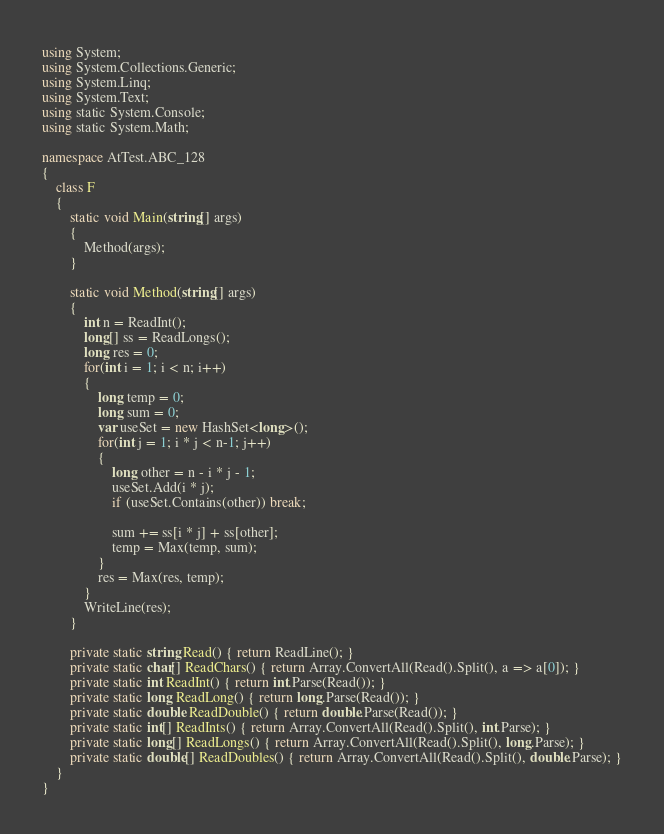Convert code to text. <code><loc_0><loc_0><loc_500><loc_500><_C#_>using System;
using System.Collections.Generic;
using System.Linq;
using System.Text;
using static System.Console;
using static System.Math;

namespace AtTest.ABC_128
{
    class F
    {
        static void Main(string[] args)
        {
            Method(args);
        }

        static void Method(string[] args)
        {
            int n = ReadInt();
            long[] ss = ReadLongs();
            long res = 0;
            for(int i = 1; i < n; i++)
            {
                long temp = 0;
                long sum = 0;
                var useSet = new HashSet<long>();
                for(int j = 1; i * j < n-1; j++)
                {
                    long other = n - i * j - 1;
                    useSet.Add(i * j);
                    if (useSet.Contains(other)) break;

                    sum += ss[i * j] + ss[other];
                    temp = Max(temp, sum);
                }
                res = Max(res, temp);
            }
            WriteLine(res);
        }

        private static string Read() { return ReadLine(); }
        private static char[] ReadChars() { return Array.ConvertAll(Read().Split(), a => a[0]); }
        private static int ReadInt() { return int.Parse(Read()); }
        private static long ReadLong() { return long.Parse(Read()); }
        private static double ReadDouble() { return double.Parse(Read()); }
        private static int[] ReadInts() { return Array.ConvertAll(Read().Split(), int.Parse); }
        private static long[] ReadLongs() { return Array.ConvertAll(Read().Split(), long.Parse); }
        private static double[] ReadDoubles() { return Array.ConvertAll(Read().Split(), double.Parse); }
    }
}
</code> 